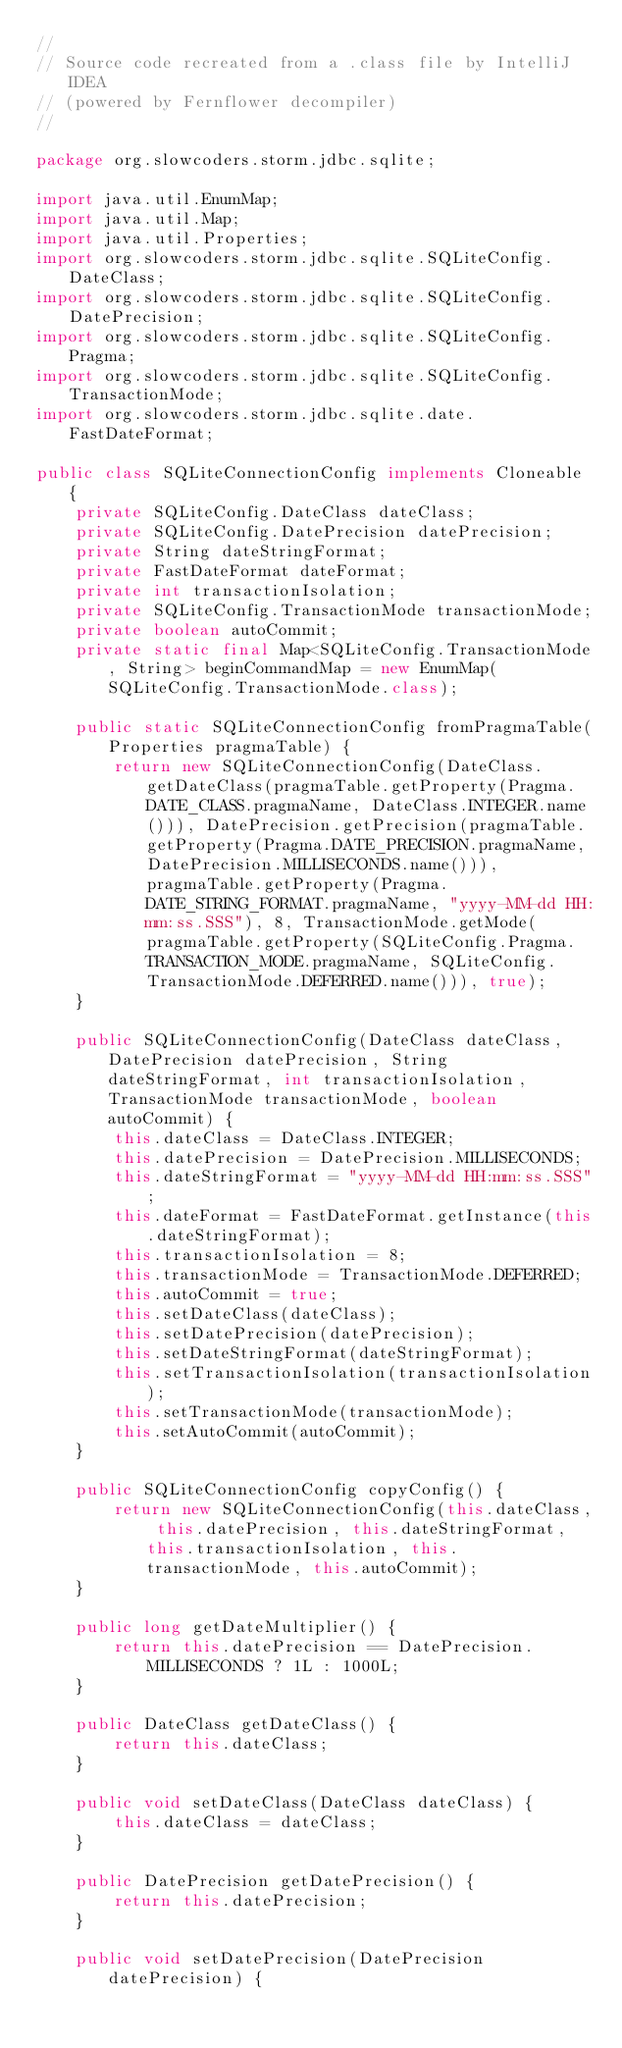Convert code to text. <code><loc_0><loc_0><loc_500><loc_500><_Java_>//
// Source code recreated from a .class file by IntelliJ IDEA
// (powered by Fernflower decompiler)
//

package org.slowcoders.storm.jdbc.sqlite;

import java.util.EnumMap;
import java.util.Map;
import java.util.Properties;
import org.slowcoders.storm.jdbc.sqlite.SQLiteConfig.DateClass;
import org.slowcoders.storm.jdbc.sqlite.SQLiteConfig.DatePrecision;
import org.slowcoders.storm.jdbc.sqlite.SQLiteConfig.Pragma;
import org.slowcoders.storm.jdbc.sqlite.SQLiteConfig.TransactionMode;
import org.slowcoders.storm.jdbc.sqlite.date.FastDateFormat;

public class SQLiteConnectionConfig implements Cloneable {
    private SQLiteConfig.DateClass dateClass;
    private SQLiteConfig.DatePrecision datePrecision;
    private String dateStringFormat;
    private FastDateFormat dateFormat;
    private int transactionIsolation;
    private SQLiteConfig.TransactionMode transactionMode;
    private boolean autoCommit;
    private static final Map<SQLiteConfig.TransactionMode, String> beginCommandMap = new EnumMap(SQLiteConfig.TransactionMode.class);

    public static SQLiteConnectionConfig fromPragmaTable(Properties pragmaTable) {
        return new SQLiteConnectionConfig(DateClass.getDateClass(pragmaTable.getProperty(Pragma.DATE_CLASS.pragmaName, DateClass.INTEGER.name())), DatePrecision.getPrecision(pragmaTable.getProperty(Pragma.DATE_PRECISION.pragmaName, DatePrecision.MILLISECONDS.name())), pragmaTable.getProperty(Pragma.DATE_STRING_FORMAT.pragmaName, "yyyy-MM-dd HH:mm:ss.SSS"), 8, TransactionMode.getMode(pragmaTable.getProperty(SQLiteConfig.Pragma.TRANSACTION_MODE.pragmaName, SQLiteConfig.TransactionMode.DEFERRED.name())), true);
    }

    public SQLiteConnectionConfig(DateClass dateClass, DatePrecision datePrecision, String dateStringFormat, int transactionIsolation, TransactionMode transactionMode, boolean autoCommit) {
        this.dateClass = DateClass.INTEGER;
        this.datePrecision = DatePrecision.MILLISECONDS;
        this.dateStringFormat = "yyyy-MM-dd HH:mm:ss.SSS";
        this.dateFormat = FastDateFormat.getInstance(this.dateStringFormat);
        this.transactionIsolation = 8;
        this.transactionMode = TransactionMode.DEFERRED;
        this.autoCommit = true;
        this.setDateClass(dateClass);
        this.setDatePrecision(datePrecision);
        this.setDateStringFormat(dateStringFormat);
        this.setTransactionIsolation(transactionIsolation);
        this.setTransactionMode(transactionMode);
        this.setAutoCommit(autoCommit);
    }

    public SQLiteConnectionConfig copyConfig() {
        return new SQLiteConnectionConfig(this.dateClass, this.datePrecision, this.dateStringFormat, this.transactionIsolation, this.transactionMode, this.autoCommit);
    }

    public long getDateMultiplier() {
        return this.datePrecision == DatePrecision.MILLISECONDS ? 1L : 1000L;
    }

    public DateClass getDateClass() {
        return this.dateClass;
    }

    public void setDateClass(DateClass dateClass) {
        this.dateClass = dateClass;
    }

    public DatePrecision getDatePrecision() {
        return this.datePrecision;
    }

    public void setDatePrecision(DatePrecision datePrecision) {</code> 